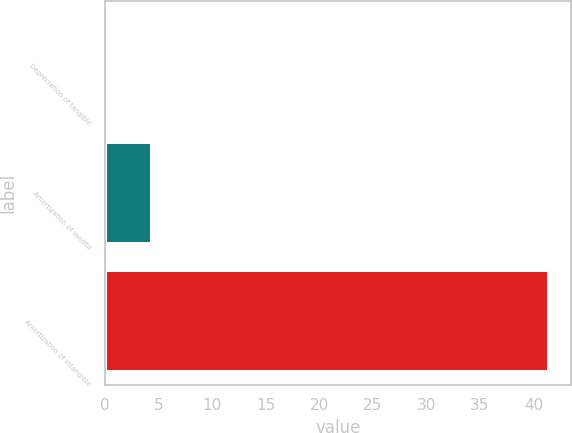<chart> <loc_0><loc_0><loc_500><loc_500><bar_chart><fcel>Depreciation of tangible<fcel>Amortization of landfill<fcel>Amortization of intangible<nl><fcel>0.3<fcel>4.41<fcel>41.4<nl></chart> 